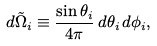Convert formula to latex. <formula><loc_0><loc_0><loc_500><loc_500>d \tilde { \Omega } _ { i } \equiv \frac { \sin \theta _ { i } } { 4 \pi } \, d \theta _ { i } \, d \phi _ { i } ,</formula> 